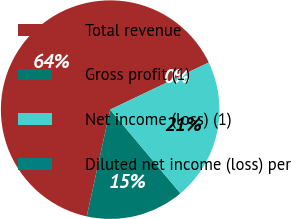<chart> <loc_0><loc_0><loc_500><loc_500><pie_chart><fcel>Total revenue<fcel>Gross profit (1)<fcel>Net income (loss) (1)<fcel>Diluted net income (loss) per<nl><fcel>64.46%<fcel>14.55%<fcel>20.99%<fcel>0.0%<nl></chart> 